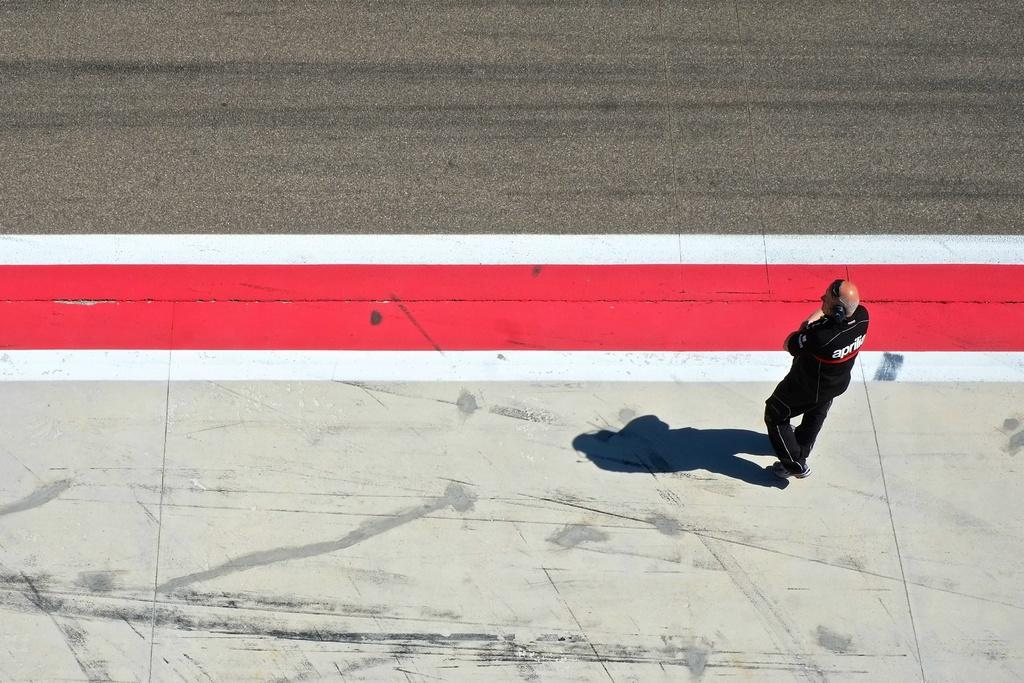What is the main subject of the image? There is a person in the image. What is the person wearing? The person is wearing a black color dress. What is the person doing in the image? The person is walking on a footpath. Can you describe the person's shadow in the image? The person has a shadow in the image. What colors are the lines near the person? The lines near the person are red and white color. What can be seen in the background of the image? There is a road in the background of the image. What type of star can be seen singing songs at the event in the image? There is no star or event present in the image; it features a person walking on a footpath. What type of songs is the person singing in the image? The person is not singing in the image; they are walking on a footpath. 